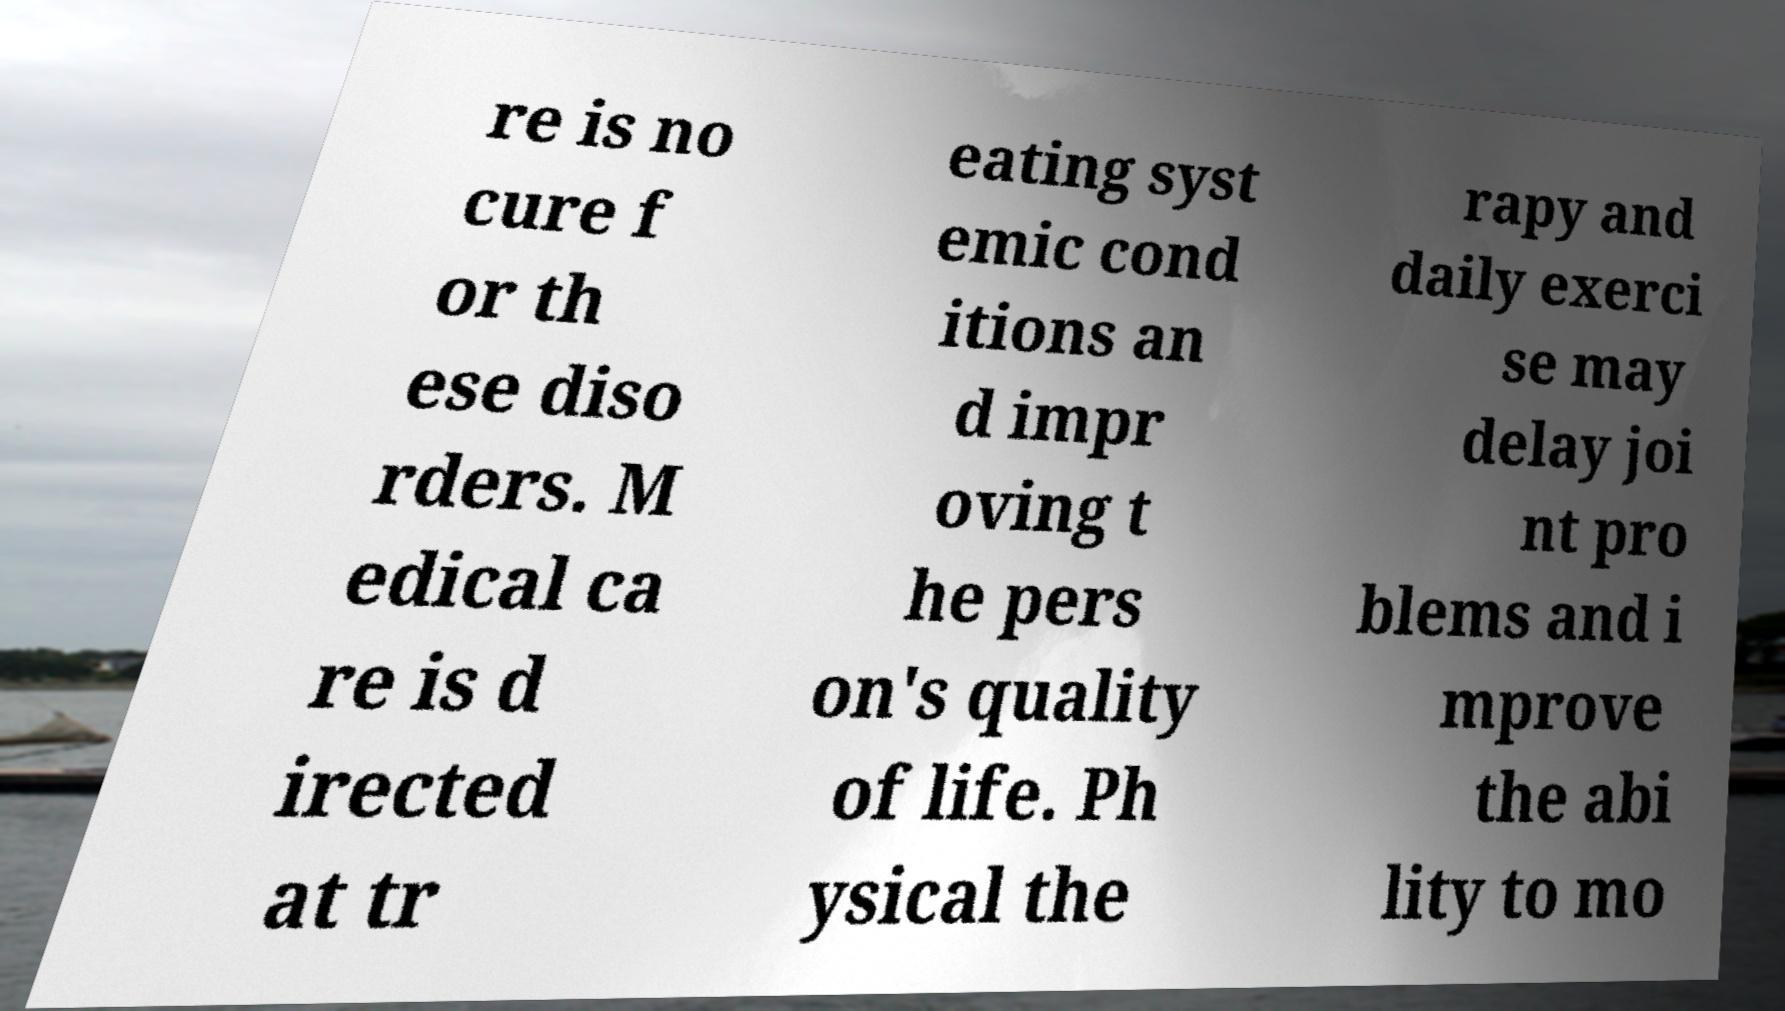Please identify and transcribe the text found in this image. re is no cure f or th ese diso rders. M edical ca re is d irected at tr eating syst emic cond itions an d impr oving t he pers on's quality of life. Ph ysical the rapy and daily exerci se may delay joi nt pro blems and i mprove the abi lity to mo 